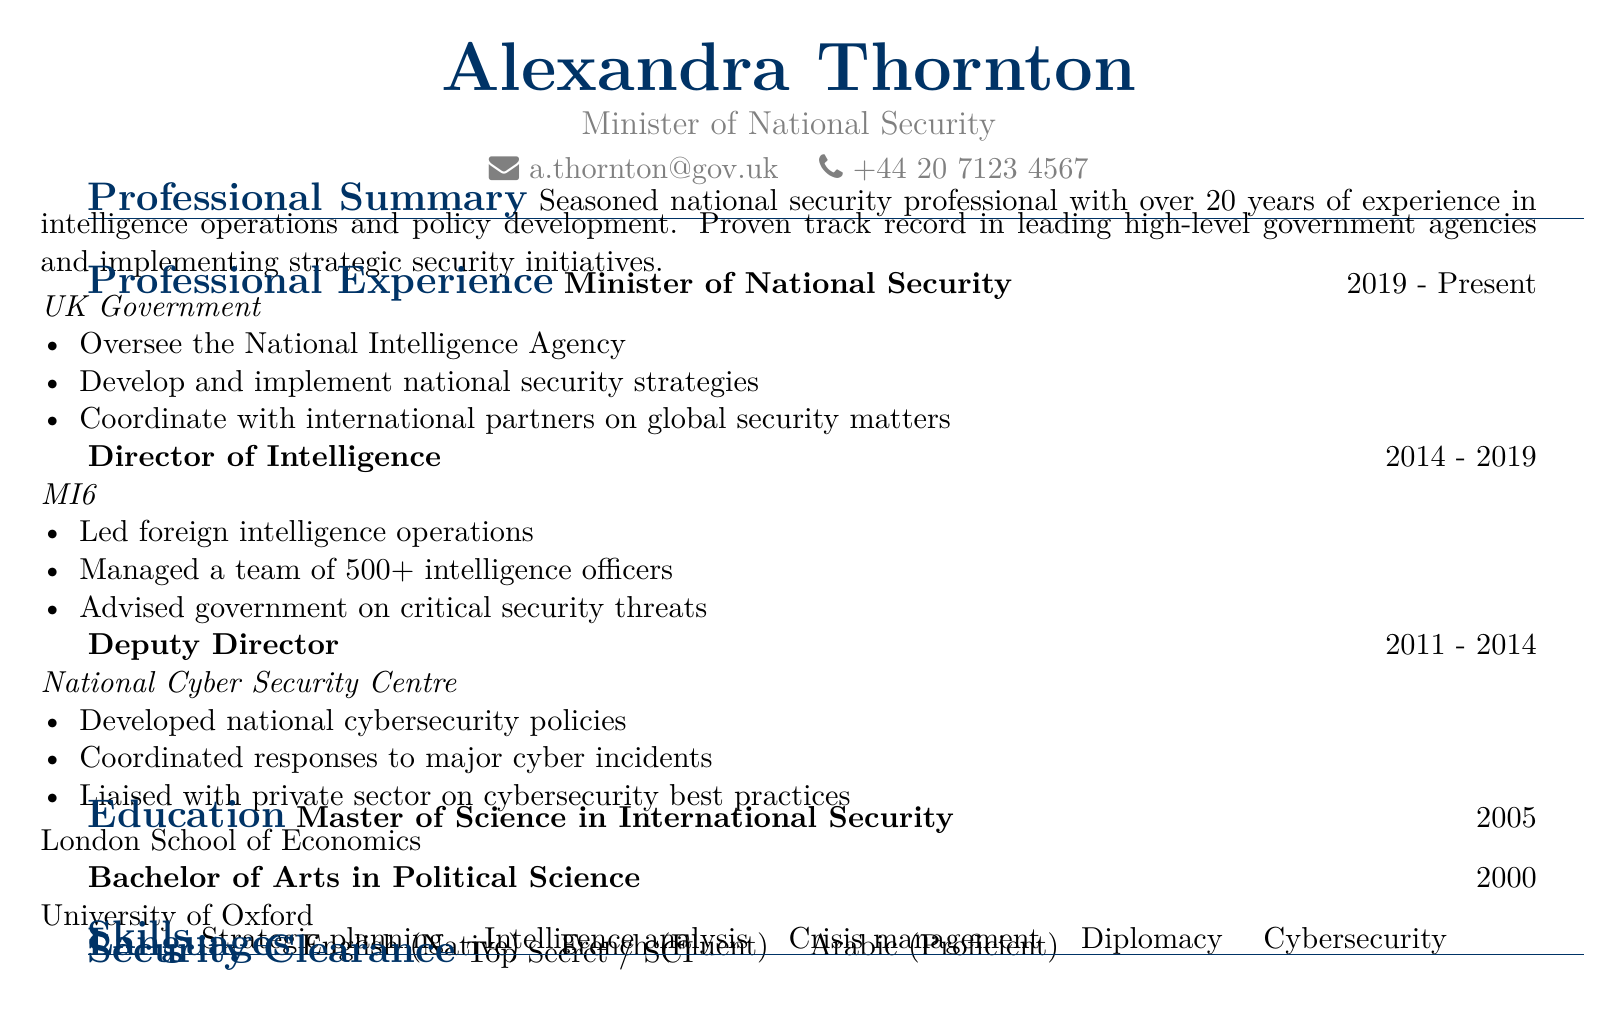What is the name of the Minister of National Security? The document lists the name of the Minister as Alexandra Thornton.
Answer: Alexandra Thornton What organization does Alexandra Thornton oversee? The document states that she oversees the National Intelligence Agency.
Answer: National Intelligence Agency How many years of experience does Alexandra Thornton have in national security? According to the document, she has over 20 years of experience in national security.
Answer: Over 20 years What was Alexandra Thornton's position at MI6? The document indicates that she held the position of Director of Intelligence at MI6.
Answer: Director of Intelligence In which year did Alexandra Thornton obtain her Master's degree? The document mentions that she obtained her Master's degree in 2005.
Answer: 2005 What type of security clearance does Alexandra Thornton have? The document specifies that she has Top Secret / SCI security clearance.
Answer: Top Secret / SCI Which language is Alexandra Thornton proficient in besides English and French? The document lists Arabic as a language in which she is proficient.
Answer: Arabic What was a responsibility of the Deputy Director at the National Cyber Security Centre? The document states that she coordinated responses to major cyber incidents as a responsibility of her role.
Answer: Coordinated responses to major cyber incidents How many intelligence officers did Alexandra Thornton manage at MI6? The document mentions that she managed a team of over 500 intelligence officers.
Answer: 500+ 